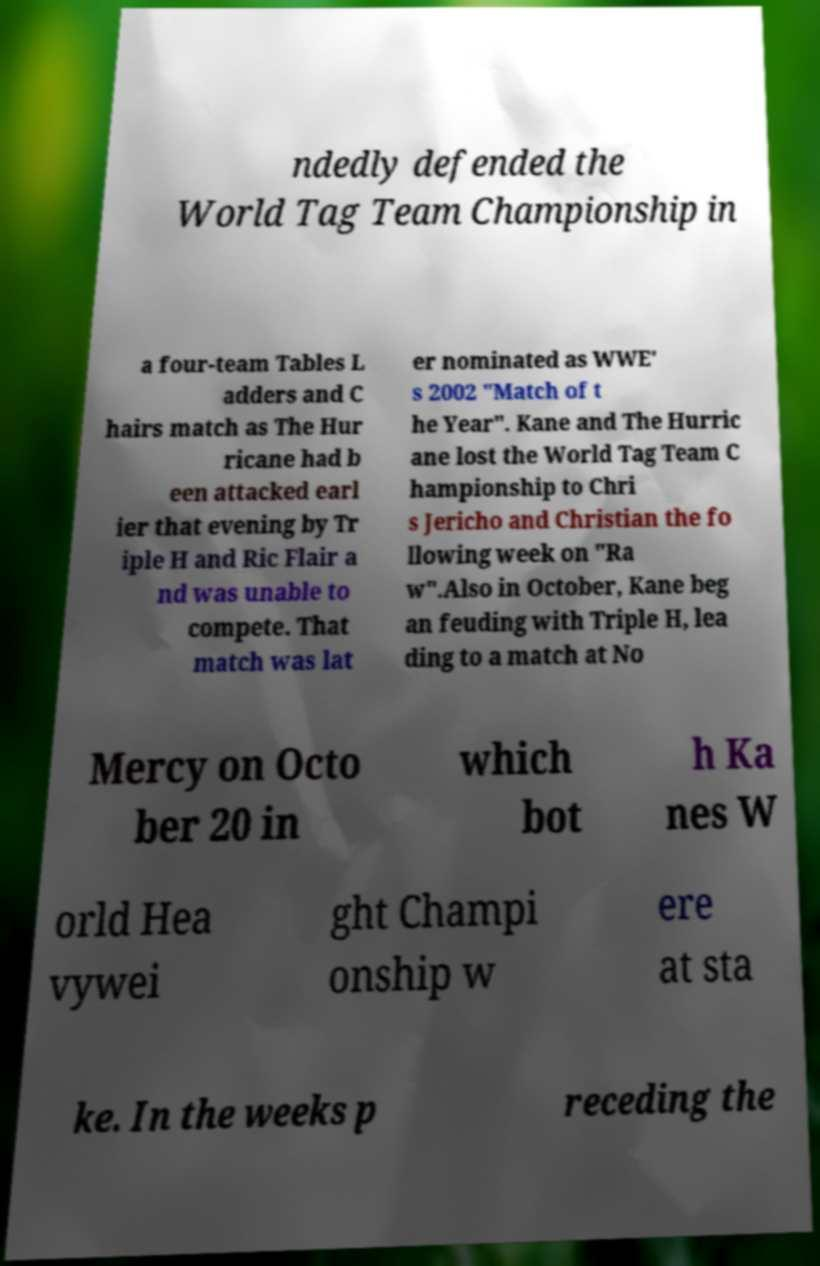Please identify and transcribe the text found in this image. ndedly defended the World Tag Team Championship in a four-team Tables L adders and C hairs match as The Hur ricane had b een attacked earl ier that evening by Tr iple H and Ric Flair a nd was unable to compete. That match was lat er nominated as WWE' s 2002 "Match of t he Year". Kane and The Hurric ane lost the World Tag Team C hampionship to Chri s Jericho and Christian the fo llowing week on "Ra w".Also in October, Kane beg an feuding with Triple H, lea ding to a match at No Mercy on Octo ber 20 in which bot h Ka nes W orld Hea vywei ght Champi onship w ere at sta ke. In the weeks p receding the 